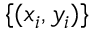Convert formula to latex. <formula><loc_0><loc_0><loc_500><loc_500>\{ ( x _ { i } , y _ { i } ) \}</formula> 